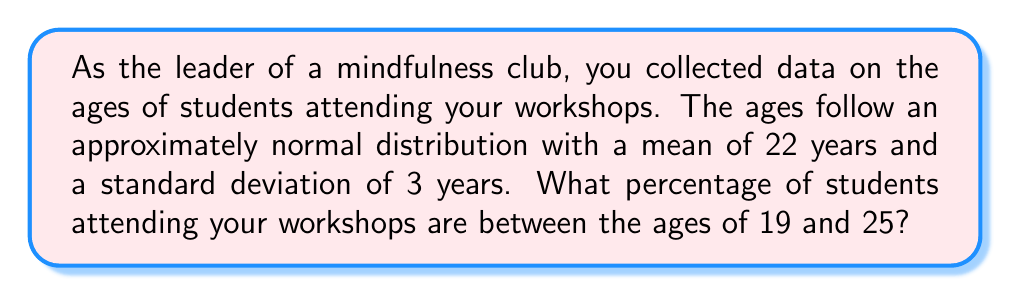Provide a solution to this math problem. To solve this problem, we need to use the properties of the normal distribution and the z-score formula. Here's a step-by-step approach:

1. Identify the given information:
   - Mean (μ) = 22 years
   - Standard deviation (σ) = 3 years
   - We want to find the percentage between 19 and 25 years

2. Calculate the z-scores for the lower and upper bounds:
   For 19 years: $z_1 = \frac{x - \mu}{\sigma} = \frac{19 - 22}{3} = -1$
   For 25 years: $z_2 = \frac{x - \mu}{\sigma} = \frac{25 - 22}{3} = 1$

3. Use a standard normal distribution table or calculator to find the area between these z-scores:
   Area between z = -1 and z = 1 is approximately 0.6826 or 68.26%

4. This area represents the percentage of students between 19 and 25 years old.

Therefore, approximately 68.26% of students attending the mindfulness workshops are between 19 and 25 years old.
Answer: 68.26% 